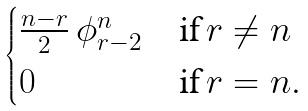<formula> <loc_0><loc_0><loc_500><loc_500>\begin{cases} \frac { n - r } { 2 } \, \phi ^ { n } _ { r - 2 } & \text {if} \, r \neq n \\ 0 & \text {if} \, r = n . \\ \end{cases}</formula> 